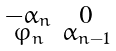<formula> <loc_0><loc_0><loc_500><loc_500>\begin{smallmatrix} - \alpha _ { n } & 0 \\ \varphi _ { n } & \alpha _ { n - 1 } \end{smallmatrix}</formula> 